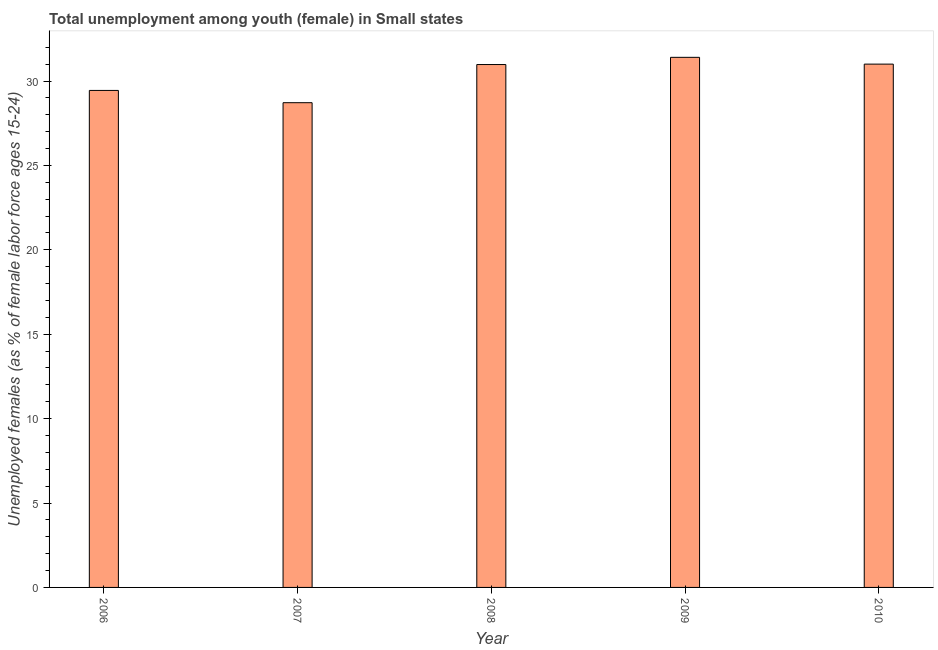Does the graph contain grids?
Offer a terse response. No. What is the title of the graph?
Offer a very short reply. Total unemployment among youth (female) in Small states. What is the label or title of the X-axis?
Provide a short and direct response. Year. What is the label or title of the Y-axis?
Provide a succinct answer. Unemployed females (as % of female labor force ages 15-24). What is the unemployed female youth population in 2006?
Provide a succinct answer. 29.44. Across all years, what is the maximum unemployed female youth population?
Ensure brevity in your answer.  31.4. Across all years, what is the minimum unemployed female youth population?
Your answer should be very brief. 28.72. In which year was the unemployed female youth population maximum?
Your answer should be compact. 2009. In which year was the unemployed female youth population minimum?
Keep it short and to the point. 2007. What is the sum of the unemployed female youth population?
Make the answer very short. 151.55. What is the difference between the unemployed female youth population in 2007 and 2009?
Offer a terse response. -2.69. What is the average unemployed female youth population per year?
Provide a succinct answer. 30.31. What is the median unemployed female youth population?
Provide a succinct answer. 30.98. In how many years, is the unemployed female youth population greater than 18 %?
Your answer should be compact. 5. Is the unemployed female youth population in 2006 less than that in 2009?
Ensure brevity in your answer.  Yes. Is the difference between the unemployed female youth population in 2006 and 2009 greater than the difference between any two years?
Offer a terse response. No. What is the difference between the highest and the second highest unemployed female youth population?
Your response must be concise. 0.4. Is the sum of the unemployed female youth population in 2006 and 2010 greater than the maximum unemployed female youth population across all years?
Your answer should be compact. Yes. What is the difference between the highest and the lowest unemployed female youth population?
Give a very brief answer. 2.69. In how many years, is the unemployed female youth population greater than the average unemployed female youth population taken over all years?
Make the answer very short. 3. How many bars are there?
Your answer should be compact. 5. How many years are there in the graph?
Provide a succinct answer. 5. What is the difference between two consecutive major ticks on the Y-axis?
Keep it short and to the point. 5. What is the Unemployed females (as % of female labor force ages 15-24) of 2006?
Keep it short and to the point. 29.44. What is the Unemployed females (as % of female labor force ages 15-24) of 2007?
Provide a succinct answer. 28.72. What is the Unemployed females (as % of female labor force ages 15-24) of 2008?
Make the answer very short. 30.98. What is the Unemployed females (as % of female labor force ages 15-24) of 2009?
Provide a short and direct response. 31.4. What is the Unemployed females (as % of female labor force ages 15-24) in 2010?
Your answer should be compact. 31. What is the difference between the Unemployed females (as % of female labor force ages 15-24) in 2006 and 2007?
Give a very brief answer. 0.73. What is the difference between the Unemployed females (as % of female labor force ages 15-24) in 2006 and 2008?
Keep it short and to the point. -1.53. What is the difference between the Unemployed females (as % of female labor force ages 15-24) in 2006 and 2009?
Offer a terse response. -1.96. What is the difference between the Unemployed females (as % of female labor force ages 15-24) in 2006 and 2010?
Provide a succinct answer. -1.56. What is the difference between the Unemployed females (as % of female labor force ages 15-24) in 2007 and 2008?
Offer a very short reply. -2.26. What is the difference between the Unemployed females (as % of female labor force ages 15-24) in 2007 and 2009?
Offer a very short reply. -2.69. What is the difference between the Unemployed females (as % of female labor force ages 15-24) in 2007 and 2010?
Your answer should be compact. -2.29. What is the difference between the Unemployed females (as % of female labor force ages 15-24) in 2008 and 2009?
Ensure brevity in your answer.  -0.43. What is the difference between the Unemployed females (as % of female labor force ages 15-24) in 2008 and 2010?
Make the answer very short. -0.03. What is the difference between the Unemployed females (as % of female labor force ages 15-24) in 2009 and 2010?
Your answer should be compact. 0.4. What is the ratio of the Unemployed females (as % of female labor force ages 15-24) in 2006 to that in 2008?
Your answer should be compact. 0.95. What is the ratio of the Unemployed females (as % of female labor force ages 15-24) in 2006 to that in 2009?
Your answer should be compact. 0.94. What is the ratio of the Unemployed females (as % of female labor force ages 15-24) in 2007 to that in 2008?
Offer a terse response. 0.93. What is the ratio of the Unemployed females (as % of female labor force ages 15-24) in 2007 to that in 2009?
Your response must be concise. 0.91. What is the ratio of the Unemployed females (as % of female labor force ages 15-24) in 2007 to that in 2010?
Provide a succinct answer. 0.93. What is the ratio of the Unemployed females (as % of female labor force ages 15-24) in 2008 to that in 2009?
Your answer should be compact. 0.99. What is the ratio of the Unemployed females (as % of female labor force ages 15-24) in 2008 to that in 2010?
Offer a terse response. 1. What is the ratio of the Unemployed females (as % of female labor force ages 15-24) in 2009 to that in 2010?
Provide a succinct answer. 1.01. 